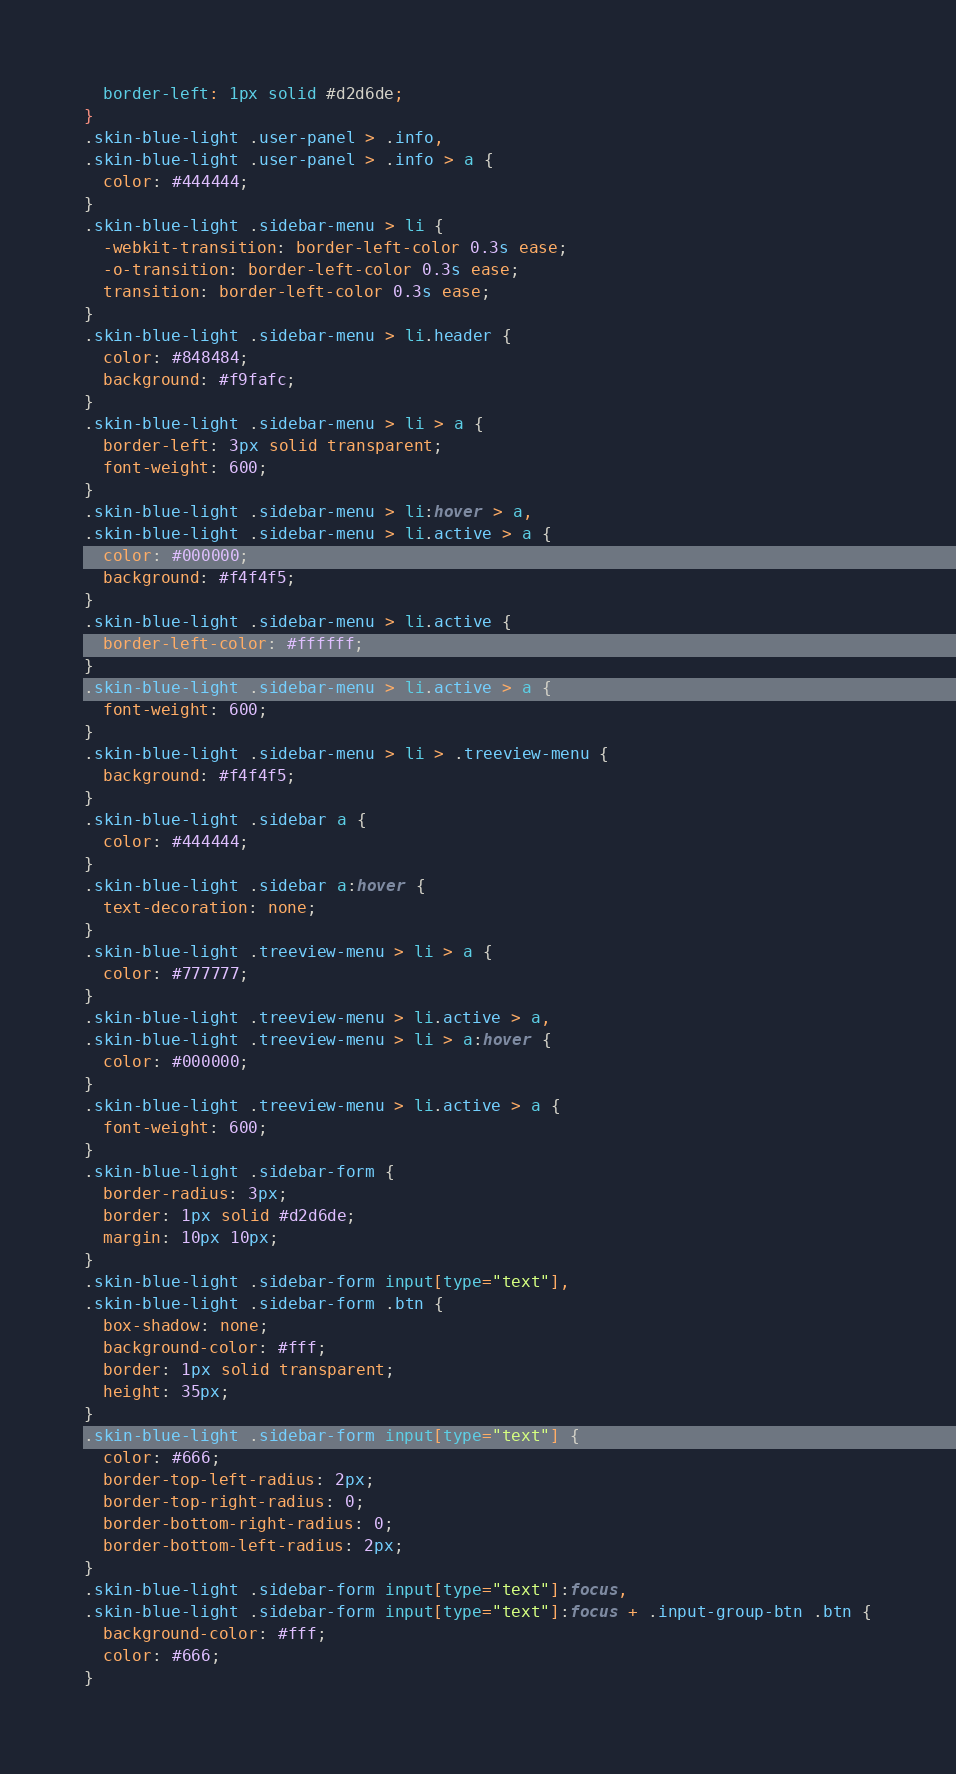Convert code to text. <code><loc_0><loc_0><loc_500><loc_500><_CSS_>  border-left: 1px solid #d2d6de;
}
.skin-blue-light .user-panel > .info,
.skin-blue-light .user-panel > .info > a {
  color: #444444;
}
.skin-blue-light .sidebar-menu > li {
  -webkit-transition: border-left-color 0.3s ease;
  -o-transition: border-left-color 0.3s ease;
  transition: border-left-color 0.3s ease;
}
.skin-blue-light .sidebar-menu > li.header {
  color: #848484;
  background: #f9fafc;
}
.skin-blue-light .sidebar-menu > li > a {
  border-left: 3px solid transparent;
  font-weight: 600;
}
.skin-blue-light .sidebar-menu > li:hover > a,
.skin-blue-light .sidebar-menu > li.active > a {
  color: #000000;
  background: #f4f4f5;
}
.skin-blue-light .sidebar-menu > li.active {
  border-left-color: #ffffff;
}
.skin-blue-light .sidebar-menu > li.active > a {
  font-weight: 600;
}
.skin-blue-light .sidebar-menu > li > .treeview-menu {
  background: #f4f4f5;
}
.skin-blue-light .sidebar a {
  color: #444444;
}
.skin-blue-light .sidebar a:hover {
  text-decoration: none;
}
.skin-blue-light .treeview-menu > li > a {
  color: #777777;
}
.skin-blue-light .treeview-menu > li.active > a,
.skin-blue-light .treeview-menu > li > a:hover {
  color: #000000;
}
.skin-blue-light .treeview-menu > li.active > a {
  font-weight: 600;
}
.skin-blue-light .sidebar-form {
  border-radius: 3px;
  border: 1px solid #d2d6de;
  margin: 10px 10px;
}
.skin-blue-light .sidebar-form input[type="text"],
.skin-blue-light .sidebar-form .btn {
  box-shadow: none;
  background-color: #fff;
  border: 1px solid transparent;
  height: 35px;
}
.skin-blue-light .sidebar-form input[type="text"] {
  color: #666;
  border-top-left-radius: 2px;
  border-top-right-radius: 0;
  border-bottom-right-radius: 0;
  border-bottom-left-radius: 2px;
}
.skin-blue-light .sidebar-form input[type="text"]:focus,
.skin-blue-light .sidebar-form input[type="text"]:focus + .input-group-btn .btn {
  background-color: #fff;
  color: #666;
}</code> 